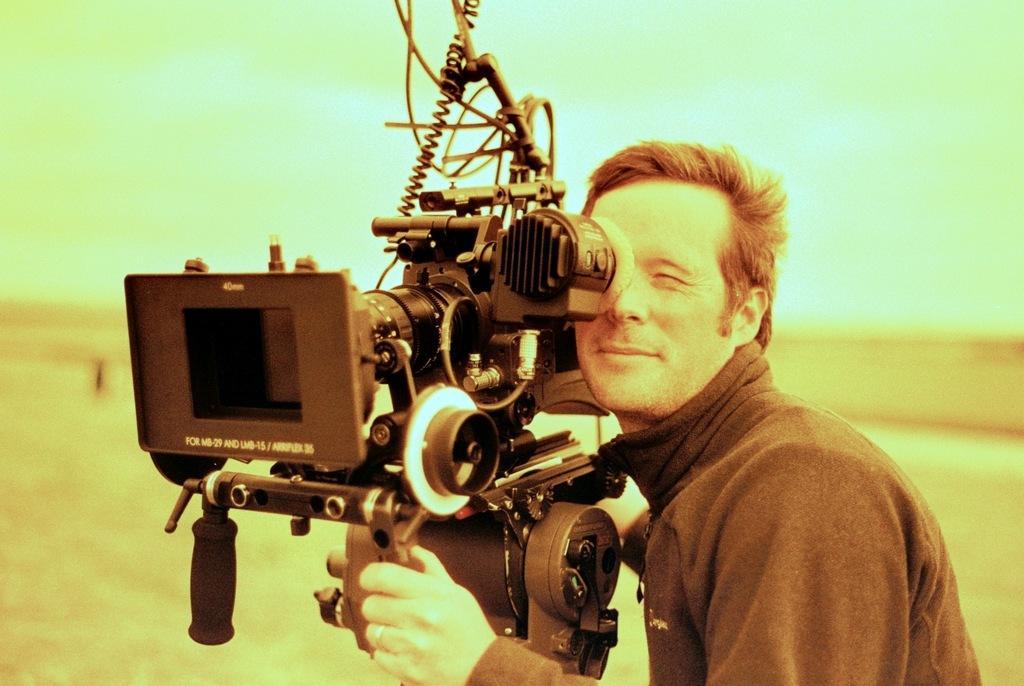Could you give a brief overview of what you see in this image? On the right side, there is a person in a T-shirt, holding the handle of the camera and watching something through the camera. In the background, there is a ground, there are clouds in the sky. 